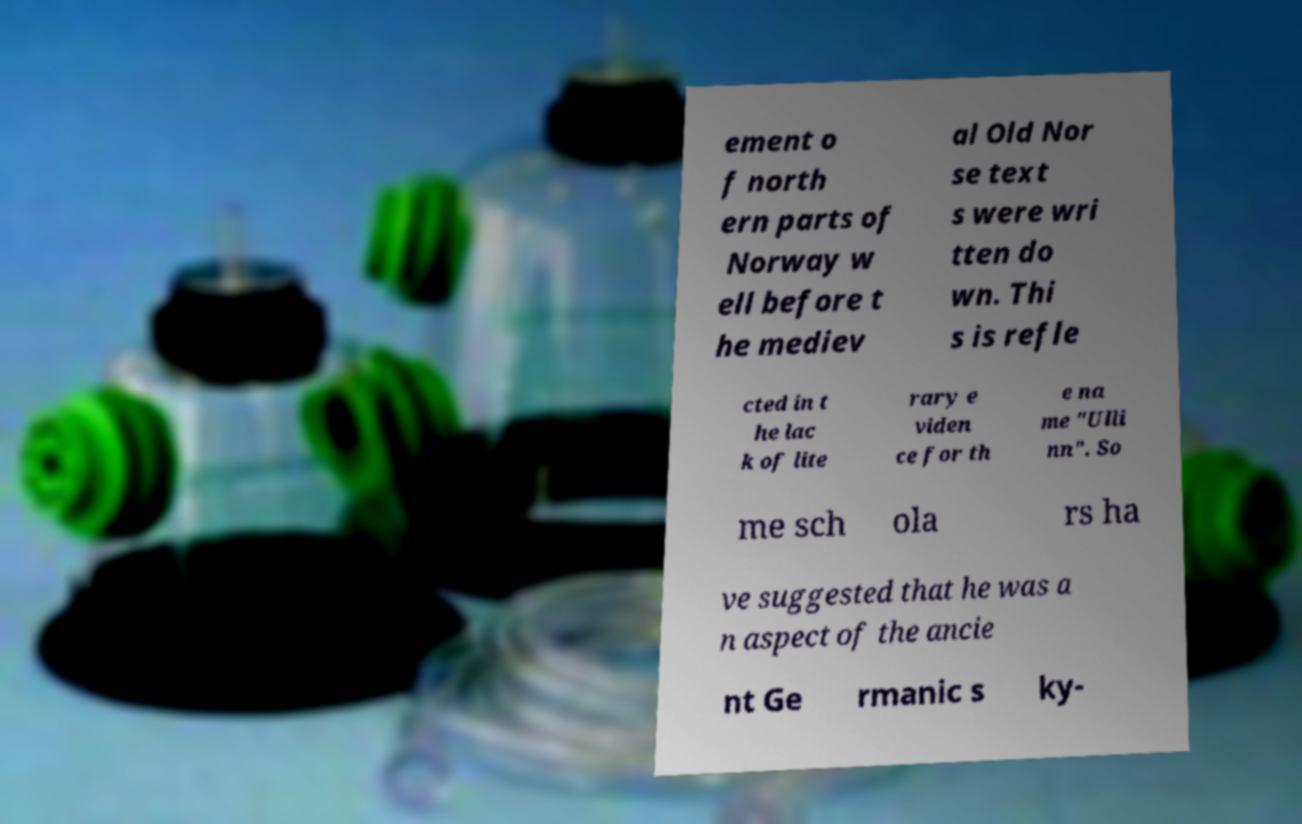For documentation purposes, I need the text within this image transcribed. Could you provide that? ement o f north ern parts of Norway w ell before t he mediev al Old Nor se text s were wri tten do wn. Thi s is refle cted in t he lac k of lite rary e viden ce for th e na me "Ulli nn". So me sch ola rs ha ve suggested that he was a n aspect of the ancie nt Ge rmanic s ky- 